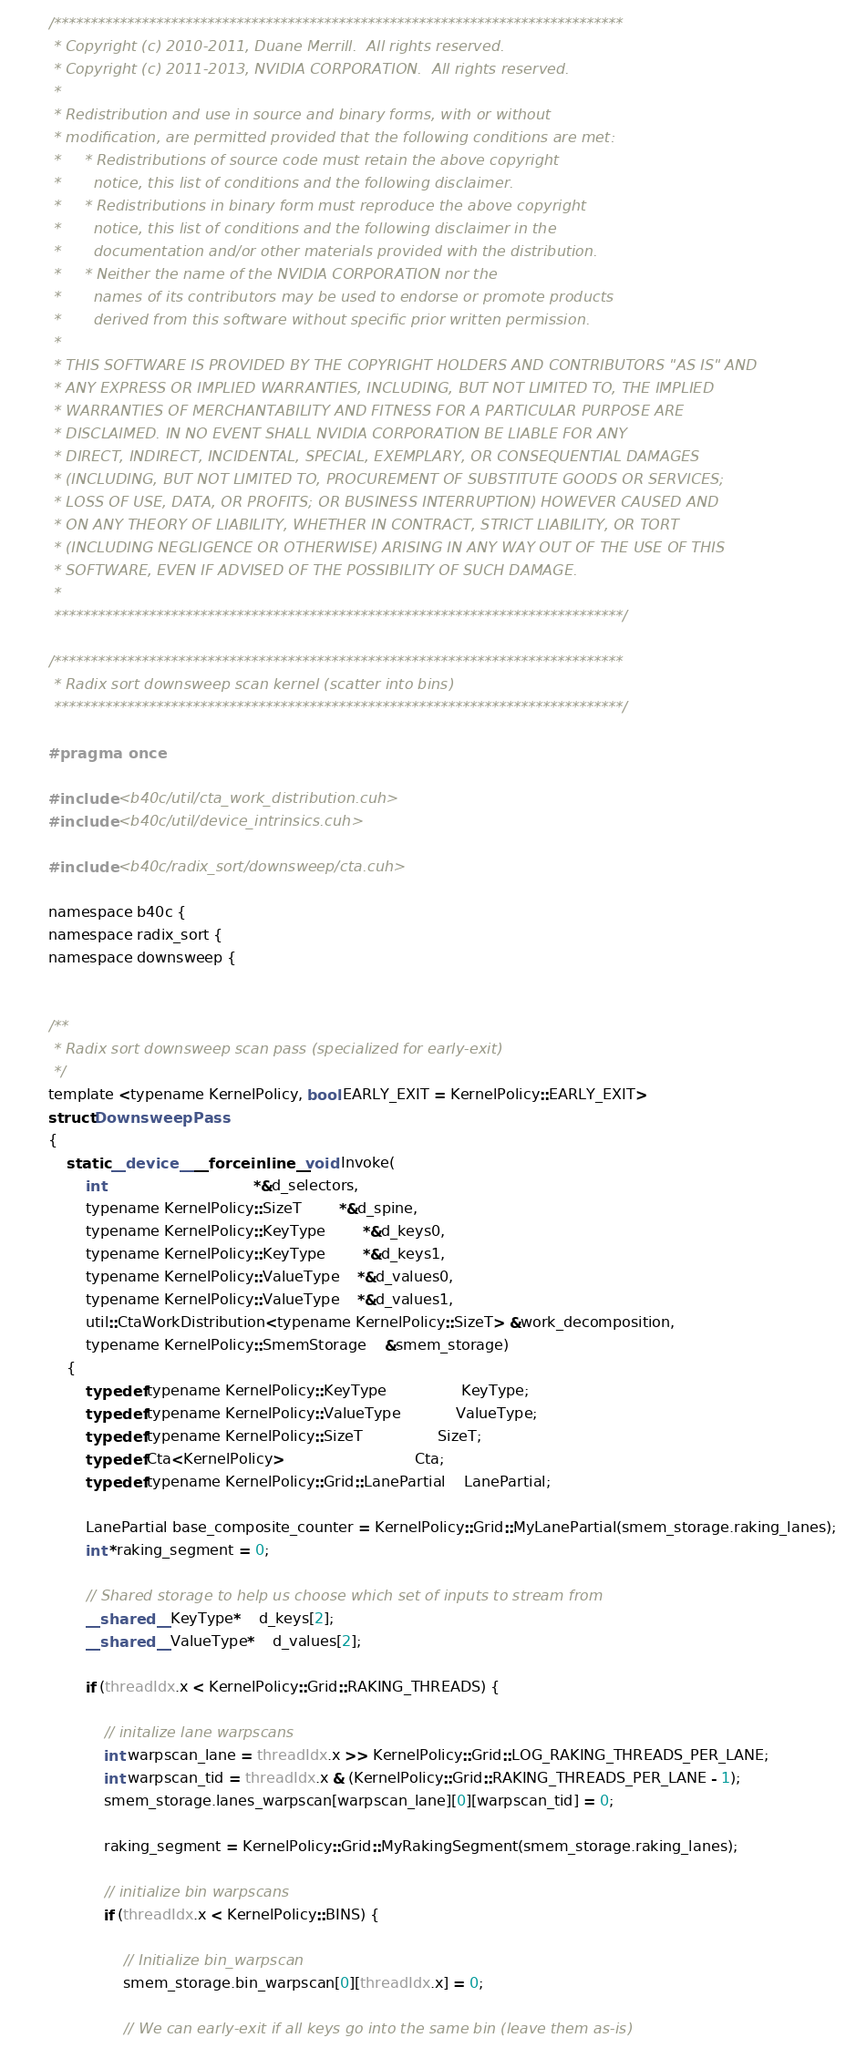<code> <loc_0><loc_0><loc_500><loc_500><_Cuda_>/******************************************************************************
 * Copyright (c) 2010-2011, Duane Merrill.  All rights reserved.
 * Copyright (c) 2011-2013, NVIDIA CORPORATION.  All rights reserved.
 * 
 * Redistribution and use in source and binary forms, with or without
 * modification, are permitted provided that the following conditions are met:
 *     * Redistributions of source code must retain the above copyright
 *       notice, this list of conditions and the following disclaimer.
 *     * Redistributions in binary form must reproduce the above copyright
 *       notice, this list of conditions and the following disclaimer in the
 *       documentation and/or other materials provided with the distribution.
 *     * Neither the name of the NVIDIA CORPORATION nor the
 *       names of its contributors may be used to endorse or promote products
 *       derived from this software without specific prior written permission.
 * 
 * THIS SOFTWARE IS PROVIDED BY THE COPYRIGHT HOLDERS AND CONTRIBUTORS "AS IS" AND
 * ANY EXPRESS OR IMPLIED WARRANTIES, INCLUDING, BUT NOT LIMITED TO, THE IMPLIED
 * WARRANTIES OF MERCHANTABILITY AND FITNESS FOR A PARTICULAR PURPOSE ARE
 * DISCLAIMED. IN NO EVENT SHALL NVIDIA CORPORATION BE LIABLE FOR ANY
 * DIRECT, INDIRECT, INCIDENTAL, SPECIAL, EXEMPLARY, OR CONSEQUENTIAL DAMAGES
 * (INCLUDING, BUT NOT LIMITED TO, PROCUREMENT OF SUBSTITUTE GOODS OR SERVICES;
 * LOSS OF USE, DATA, OR PROFITS; OR BUSINESS INTERRUPTION) HOWEVER CAUSED AND
 * ON ANY THEORY OF LIABILITY, WHETHER IN CONTRACT, STRICT LIABILITY, OR TORT
 * (INCLUDING NEGLIGENCE OR OTHERWISE) ARISING IN ANY WAY OUT OF THE USE OF THIS
 * SOFTWARE, EVEN IF ADVISED OF THE POSSIBILITY OF SUCH DAMAGE.
 *
 ******************************************************************************/

/******************************************************************************
 * Radix sort downsweep scan kernel (scatter into bins)
 ******************************************************************************/

#pragma once

#include <b40c/util/cta_work_distribution.cuh>
#include <b40c/util/device_intrinsics.cuh>

#include <b40c/radix_sort/downsweep/cta.cuh>

namespace b40c {
namespace radix_sort {
namespace downsweep {


/**
 * Radix sort downsweep scan pass (specialized for early-exit)
 */
template <typename KernelPolicy, bool EARLY_EXIT = KernelPolicy::EARLY_EXIT>
struct DownsweepPass
{
	static __device__ __forceinline__ void Invoke(
		int 								*&d_selectors,
		typename KernelPolicy::SizeT 		*&d_spine,
		typename KernelPolicy::KeyType 		*&d_keys0,
		typename KernelPolicy::KeyType 		*&d_keys1,
		typename KernelPolicy::ValueType 	*&d_values0,
		typename KernelPolicy::ValueType 	*&d_values1,
		util::CtaWorkDistribution<typename KernelPolicy::SizeT> &work_decomposition,
		typename KernelPolicy::SmemStorage	&smem_storage)
	{
		typedef typename KernelPolicy::KeyType 				KeyType;
		typedef typename KernelPolicy::ValueType 			ValueType;
		typedef typename KernelPolicy::SizeT 				SizeT;
		typedef Cta<KernelPolicy> 							Cta;
		typedef typename KernelPolicy::Grid::LanePartial	LanePartial;

		LanePartial base_composite_counter = KernelPolicy::Grid::MyLanePartial(smem_storage.raking_lanes);
		int *raking_segment = 0;

		// Shared storage to help us choose which set of inputs to stream from
		__shared__ KeyType* 	d_keys[2];
		__shared__ ValueType* 	d_values[2];

		if (threadIdx.x < KernelPolicy::Grid::RAKING_THREADS) {

			// initalize lane warpscans
			int warpscan_lane = threadIdx.x >> KernelPolicy::Grid::LOG_RAKING_THREADS_PER_LANE;
			int warpscan_tid = threadIdx.x & (KernelPolicy::Grid::RAKING_THREADS_PER_LANE - 1);
			smem_storage.lanes_warpscan[warpscan_lane][0][warpscan_tid] = 0;

			raking_segment = KernelPolicy::Grid::MyRakingSegment(smem_storage.raking_lanes);

			// initialize bin warpscans
			if (threadIdx.x < KernelPolicy::BINS) {

				// Initialize bin_warpscan
				smem_storage.bin_warpscan[0][threadIdx.x] = 0;

				// We can early-exit if all keys go into the same bin (leave them as-is)</code> 